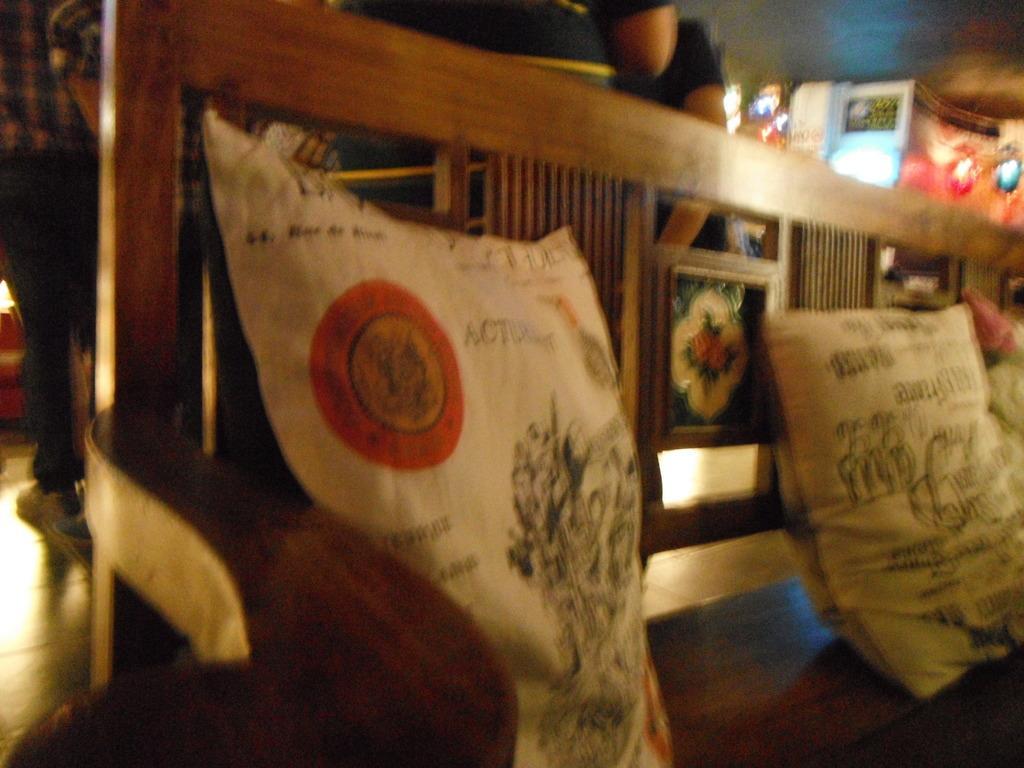In one or two sentences, can you explain what this image depicts? These are the two pillows on the wooden bench chair. 